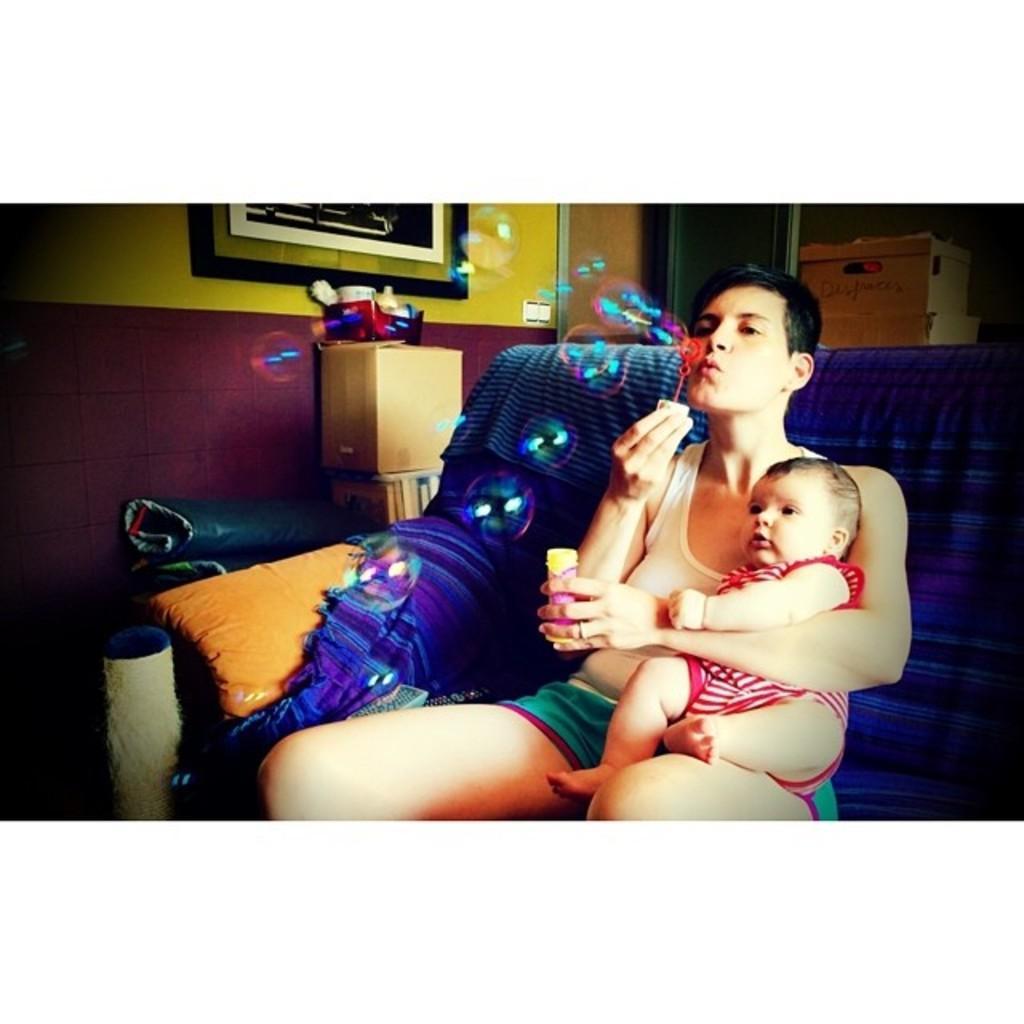How would you summarize this image in a sentence or two? There is a woman sitting in the sofa. She is blowing soap bubbles. She is holding a baby in her arms. At the background of the image there are some boxes. At the left side of the image there is a wall. 